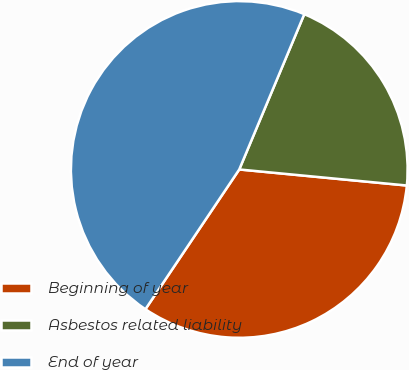Convert chart to OTSL. <chart><loc_0><loc_0><loc_500><loc_500><pie_chart><fcel>Beginning of year<fcel>Asbestos related liability<fcel>End of year<nl><fcel>32.89%<fcel>20.21%<fcel>46.9%<nl></chart> 